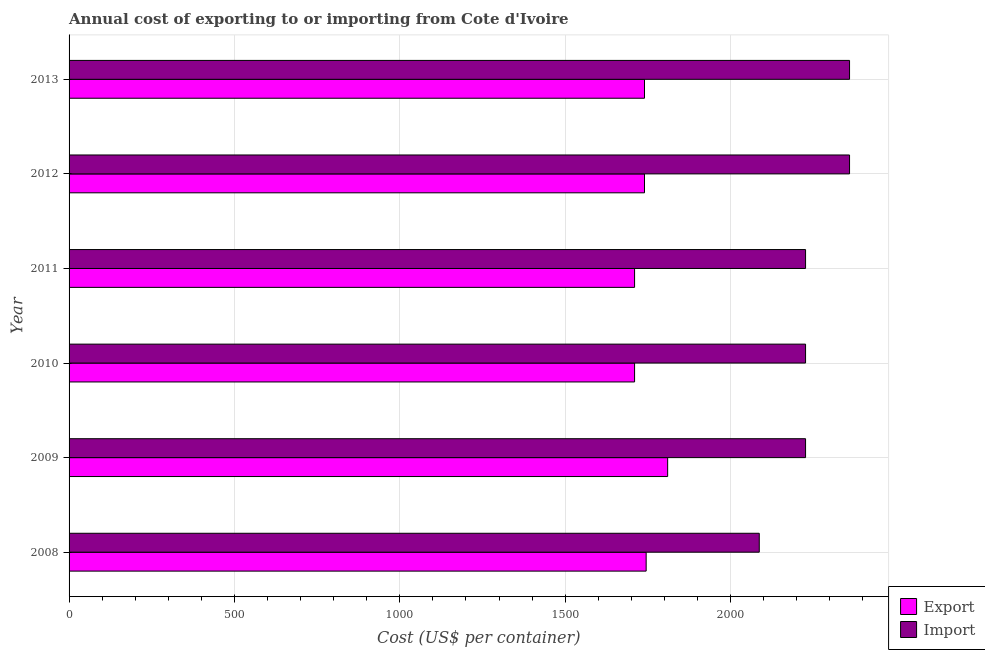How many groups of bars are there?
Offer a very short reply. 6. How many bars are there on the 4th tick from the top?
Ensure brevity in your answer.  2. What is the import cost in 2013?
Keep it short and to the point. 2360. Across all years, what is the maximum import cost?
Offer a terse response. 2360. Across all years, what is the minimum export cost?
Ensure brevity in your answer.  1710. What is the total export cost in the graph?
Offer a terse response. 1.05e+04. What is the difference between the export cost in 2011 and that in 2013?
Your answer should be compact. -30. What is the difference between the import cost in 2012 and the export cost in 2008?
Make the answer very short. 615. What is the average export cost per year?
Keep it short and to the point. 1742.5. In the year 2012, what is the difference between the import cost and export cost?
Provide a short and direct response. 620. What is the ratio of the import cost in 2012 to that in 2013?
Ensure brevity in your answer.  1. Is the export cost in 2012 less than that in 2013?
Offer a very short reply. No. What is the difference between the highest and the lowest import cost?
Your answer should be compact. 273. Is the sum of the export cost in 2011 and 2013 greater than the maximum import cost across all years?
Provide a short and direct response. Yes. What does the 2nd bar from the top in 2010 represents?
Your answer should be very brief. Export. What does the 2nd bar from the bottom in 2010 represents?
Provide a short and direct response. Import. How many bars are there?
Keep it short and to the point. 12. How many years are there in the graph?
Keep it short and to the point. 6. Does the graph contain any zero values?
Make the answer very short. No. How many legend labels are there?
Provide a short and direct response. 2. What is the title of the graph?
Ensure brevity in your answer.  Annual cost of exporting to or importing from Cote d'Ivoire. What is the label or title of the X-axis?
Make the answer very short. Cost (US$ per container). What is the Cost (US$ per container) in Export in 2008?
Your answer should be compact. 1745. What is the Cost (US$ per container) of Import in 2008?
Offer a very short reply. 2087. What is the Cost (US$ per container) in Export in 2009?
Give a very brief answer. 1810. What is the Cost (US$ per container) of Import in 2009?
Your answer should be compact. 2227. What is the Cost (US$ per container) in Export in 2010?
Offer a very short reply. 1710. What is the Cost (US$ per container) in Import in 2010?
Provide a succinct answer. 2227. What is the Cost (US$ per container) in Export in 2011?
Give a very brief answer. 1710. What is the Cost (US$ per container) of Import in 2011?
Your answer should be compact. 2227. What is the Cost (US$ per container) in Export in 2012?
Your answer should be very brief. 1740. What is the Cost (US$ per container) in Import in 2012?
Your answer should be very brief. 2360. What is the Cost (US$ per container) of Export in 2013?
Offer a terse response. 1740. What is the Cost (US$ per container) in Import in 2013?
Make the answer very short. 2360. Across all years, what is the maximum Cost (US$ per container) of Export?
Keep it short and to the point. 1810. Across all years, what is the maximum Cost (US$ per container) of Import?
Offer a terse response. 2360. Across all years, what is the minimum Cost (US$ per container) of Export?
Give a very brief answer. 1710. Across all years, what is the minimum Cost (US$ per container) in Import?
Give a very brief answer. 2087. What is the total Cost (US$ per container) in Export in the graph?
Offer a terse response. 1.05e+04. What is the total Cost (US$ per container) in Import in the graph?
Offer a terse response. 1.35e+04. What is the difference between the Cost (US$ per container) in Export in 2008 and that in 2009?
Your answer should be compact. -65. What is the difference between the Cost (US$ per container) of Import in 2008 and that in 2009?
Ensure brevity in your answer.  -140. What is the difference between the Cost (US$ per container) in Import in 2008 and that in 2010?
Provide a short and direct response. -140. What is the difference between the Cost (US$ per container) of Export in 2008 and that in 2011?
Your response must be concise. 35. What is the difference between the Cost (US$ per container) of Import in 2008 and that in 2011?
Provide a succinct answer. -140. What is the difference between the Cost (US$ per container) in Import in 2008 and that in 2012?
Make the answer very short. -273. What is the difference between the Cost (US$ per container) of Export in 2008 and that in 2013?
Offer a very short reply. 5. What is the difference between the Cost (US$ per container) of Import in 2008 and that in 2013?
Your answer should be compact. -273. What is the difference between the Cost (US$ per container) in Import in 2009 and that in 2010?
Ensure brevity in your answer.  0. What is the difference between the Cost (US$ per container) of Export in 2009 and that in 2011?
Provide a short and direct response. 100. What is the difference between the Cost (US$ per container) in Import in 2009 and that in 2012?
Offer a very short reply. -133. What is the difference between the Cost (US$ per container) of Import in 2009 and that in 2013?
Offer a terse response. -133. What is the difference between the Cost (US$ per container) of Import in 2010 and that in 2011?
Give a very brief answer. 0. What is the difference between the Cost (US$ per container) of Export in 2010 and that in 2012?
Provide a short and direct response. -30. What is the difference between the Cost (US$ per container) in Import in 2010 and that in 2012?
Your response must be concise. -133. What is the difference between the Cost (US$ per container) of Import in 2010 and that in 2013?
Make the answer very short. -133. What is the difference between the Cost (US$ per container) in Import in 2011 and that in 2012?
Provide a short and direct response. -133. What is the difference between the Cost (US$ per container) of Import in 2011 and that in 2013?
Provide a succinct answer. -133. What is the difference between the Cost (US$ per container) of Export in 2008 and the Cost (US$ per container) of Import in 2009?
Offer a very short reply. -482. What is the difference between the Cost (US$ per container) in Export in 2008 and the Cost (US$ per container) in Import in 2010?
Give a very brief answer. -482. What is the difference between the Cost (US$ per container) of Export in 2008 and the Cost (US$ per container) of Import in 2011?
Provide a succinct answer. -482. What is the difference between the Cost (US$ per container) of Export in 2008 and the Cost (US$ per container) of Import in 2012?
Ensure brevity in your answer.  -615. What is the difference between the Cost (US$ per container) of Export in 2008 and the Cost (US$ per container) of Import in 2013?
Keep it short and to the point. -615. What is the difference between the Cost (US$ per container) of Export in 2009 and the Cost (US$ per container) of Import in 2010?
Your answer should be compact. -417. What is the difference between the Cost (US$ per container) in Export in 2009 and the Cost (US$ per container) in Import in 2011?
Your response must be concise. -417. What is the difference between the Cost (US$ per container) in Export in 2009 and the Cost (US$ per container) in Import in 2012?
Offer a very short reply. -550. What is the difference between the Cost (US$ per container) of Export in 2009 and the Cost (US$ per container) of Import in 2013?
Make the answer very short. -550. What is the difference between the Cost (US$ per container) of Export in 2010 and the Cost (US$ per container) of Import in 2011?
Keep it short and to the point. -517. What is the difference between the Cost (US$ per container) in Export in 2010 and the Cost (US$ per container) in Import in 2012?
Your response must be concise. -650. What is the difference between the Cost (US$ per container) of Export in 2010 and the Cost (US$ per container) of Import in 2013?
Provide a short and direct response. -650. What is the difference between the Cost (US$ per container) in Export in 2011 and the Cost (US$ per container) in Import in 2012?
Your answer should be very brief. -650. What is the difference between the Cost (US$ per container) of Export in 2011 and the Cost (US$ per container) of Import in 2013?
Your response must be concise. -650. What is the difference between the Cost (US$ per container) of Export in 2012 and the Cost (US$ per container) of Import in 2013?
Give a very brief answer. -620. What is the average Cost (US$ per container) in Export per year?
Your response must be concise. 1742.5. What is the average Cost (US$ per container) of Import per year?
Provide a short and direct response. 2248. In the year 2008, what is the difference between the Cost (US$ per container) in Export and Cost (US$ per container) in Import?
Your answer should be compact. -342. In the year 2009, what is the difference between the Cost (US$ per container) in Export and Cost (US$ per container) in Import?
Give a very brief answer. -417. In the year 2010, what is the difference between the Cost (US$ per container) of Export and Cost (US$ per container) of Import?
Offer a very short reply. -517. In the year 2011, what is the difference between the Cost (US$ per container) in Export and Cost (US$ per container) in Import?
Keep it short and to the point. -517. In the year 2012, what is the difference between the Cost (US$ per container) of Export and Cost (US$ per container) of Import?
Keep it short and to the point. -620. In the year 2013, what is the difference between the Cost (US$ per container) of Export and Cost (US$ per container) of Import?
Offer a terse response. -620. What is the ratio of the Cost (US$ per container) in Export in 2008 to that in 2009?
Provide a short and direct response. 0.96. What is the ratio of the Cost (US$ per container) in Import in 2008 to that in 2009?
Give a very brief answer. 0.94. What is the ratio of the Cost (US$ per container) of Export in 2008 to that in 2010?
Offer a very short reply. 1.02. What is the ratio of the Cost (US$ per container) of Import in 2008 to that in 2010?
Your answer should be compact. 0.94. What is the ratio of the Cost (US$ per container) of Export in 2008 to that in 2011?
Your answer should be compact. 1.02. What is the ratio of the Cost (US$ per container) of Import in 2008 to that in 2011?
Your answer should be very brief. 0.94. What is the ratio of the Cost (US$ per container) in Export in 2008 to that in 2012?
Offer a very short reply. 1. What is the ratio of the Cost (US$ per container) of Import in 2008 to that in 2012?
Your answer should be compact. 0.88. What is the ratio of the Cost (US$ per container) of Export in 2008 to that in 2013?
Your answer should be compact. 1. What is the ratio of the Cost (US$ per container) in Import in 2008 to that in 2013?
Your response must be concise. 0.88. What is the ratio of the Cost (US$ per container) of Export in 2009 to that in 2010?
Give a very brief answer. 1.06. What is the ratio of the Cost (US$ per container) of Import in 2009 to that in 2010?
Provide a succinct answer. 1. What is the ratio of the Cost (US$ per container) of Export in 2009 to that in 2011?
Your answer should be compact. 1.06. What is the ratio of the Cost (US$ per container) in Import in 2009 to that in 2011?
Offer a terse response. 1. What is the ratio of the Cost (US$ per container) of Export in 2009 to that in 2012?
Your answer should be compact. 1.04. What is the ratio of the Cost (US$ per container) of Import in 2009 to that in 2012?
Provide a short and direct response. 0.94. What is the ratio of the Cost (US$ per container) of Export in 2009 to that in 2013?
Provide a succinct answer. 1.04. What is the ratio of the Cost (US$ per container) in Import in 2009 to that in 2013?
Provide a succinct answer. 0.94. What is the ratio of the Cost (US$ per container) in Import in 2010 to that in 2011?
Ensure brevity in your answer.  1. What is the ratio of the Cost (US$ per container) in Export in 2010 to that in 2012?
Offer a terse response. 0.98. What is the ratio of the Cost (US$ per container) in Import in 2010 to that in 2012?
Give a very brief answer. 0.94. What is the ratio of the Cost (US$ per container) of Export in 2010 to that in 2013?
Provide a short and direct response. 0.98. What is the ratio of the Cost (US$ per container) in Import in 2010 to that in 2013?
Make the answer very short. 0.94. What is the ratio of the Cost (US$ per container) of Export in 2011 to that in 2012?
Make the answer very short. 0.98. What is the ratio of the Cost (US$ per container) of Import in 2011 to that in 2012?
Keep it short and to the point. 0.94. What is the ratio of the Cost (US$ per container) of Export in 2011 to that in 2013?
Offer a terse response. 0.98. What is the ratio of the Cost (US$ per container) in Import in 2011 to that in 2013?
Your answer should be very brief. 0.94. What is the ratio of the Cost (US$ per container) of Import in 2012 to that in 2013?
Make the answer very short. 1. What is the difference between the highest and the second highest Cost (US$ per container) of Import?
Offer a very short reply. 0. What is the difference between the highest and the lowest Cost (US$ per container) in Export?
Ensure brevity in your answer.  100. What is the difference between the highest and the lowest Cost (US$ per container) of Import?
Your answer should be very brief. 273. 